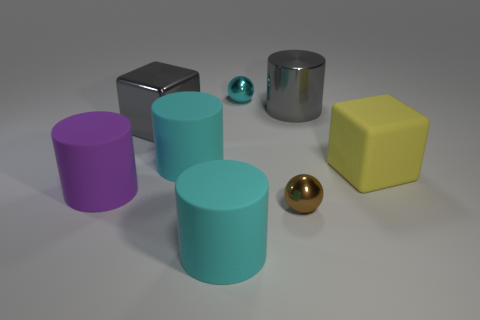There is a brown thing that is the same shape as the small cyan object; what is its material?
Offer a very short reply. Metal. There is a cyan cylinder that is behind the big cyan cylinder in front of the big cube that is to the right of the metallic cylinder; what is its size?
Your answer should be compact. Large. Do the cyan metallic object and the gray metal cylinder have the same size?
Offer a terse response. No. What is the large cube that is to the right of the sphere that is behind the tiny brown thing made of?
Offer a very short reply. Rubber. Do the large cyan matte object that is behind the matte block and the large object in front of the large purple rubber cylinder have the same shape?
Keep it short and to the point. Yes. Is the number of tiny balls that are in front of the gray metal cylinder the same as the number of big gray cubes?
Your answer should be compact. Yes. Are there any tiny brown metal objects that are behind the sphere that is in front of the big yellow thing?
Your answer should be very brief. No. Is there anything else that has the same color as the big rubber cube?
Your answer should be compact. No. Does the cylinder on the right side of the tiny cyan metallic thing have the same material as the gray block?
Your response must be concise. Yes. Are there the same number of purple objects on the left side of the large gray cylinder and big purple objects to the right of the brown ball?
Offer a very short reply. No. 